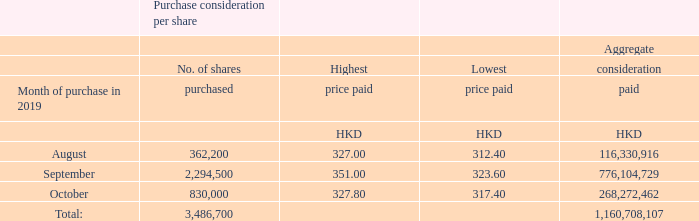During the year ended 31 December 2019, the Company repurchased 3,486,700 shares on the Stock Exchange for an aggregate consideration of approximately HKD1.16 billion before expenses. The repurchased shares were subsequently cancelled. The repurchase was effected by the Board for the enhancement of shareholder value in the long term. Details of the shares repurchased are as follows:
Save as disclosed above and in Note 32 to the consolidated financial statements, neither the Company nor any of its subsidiaries has purchased, sold or redeemed any of the Company’s shares during the year ended 31 December 2019.
How many shares did the Company repurchase during the year ended 31 December 2019? 3,486,700. How much did the Company pay for the repurchased shares?  Hkd1.16 billion. How many shares was purchased in August? 362,200. What percentage of total shares purchased is the August share purchase?
Answer scale should be: percent. 362,200/3,486,700
Answer: 10.39. What percentage of total shares purchased is the September share purchase?
Answer scale should be: percent. 2,294,500/3,486,700
Answer: 65.81. What percentage of the total aggregate consideration paid is the August aggregate consideration paid?
Answer scale should be: percent. 116,330,916/1,160,708,107
Answer: 10.02. 